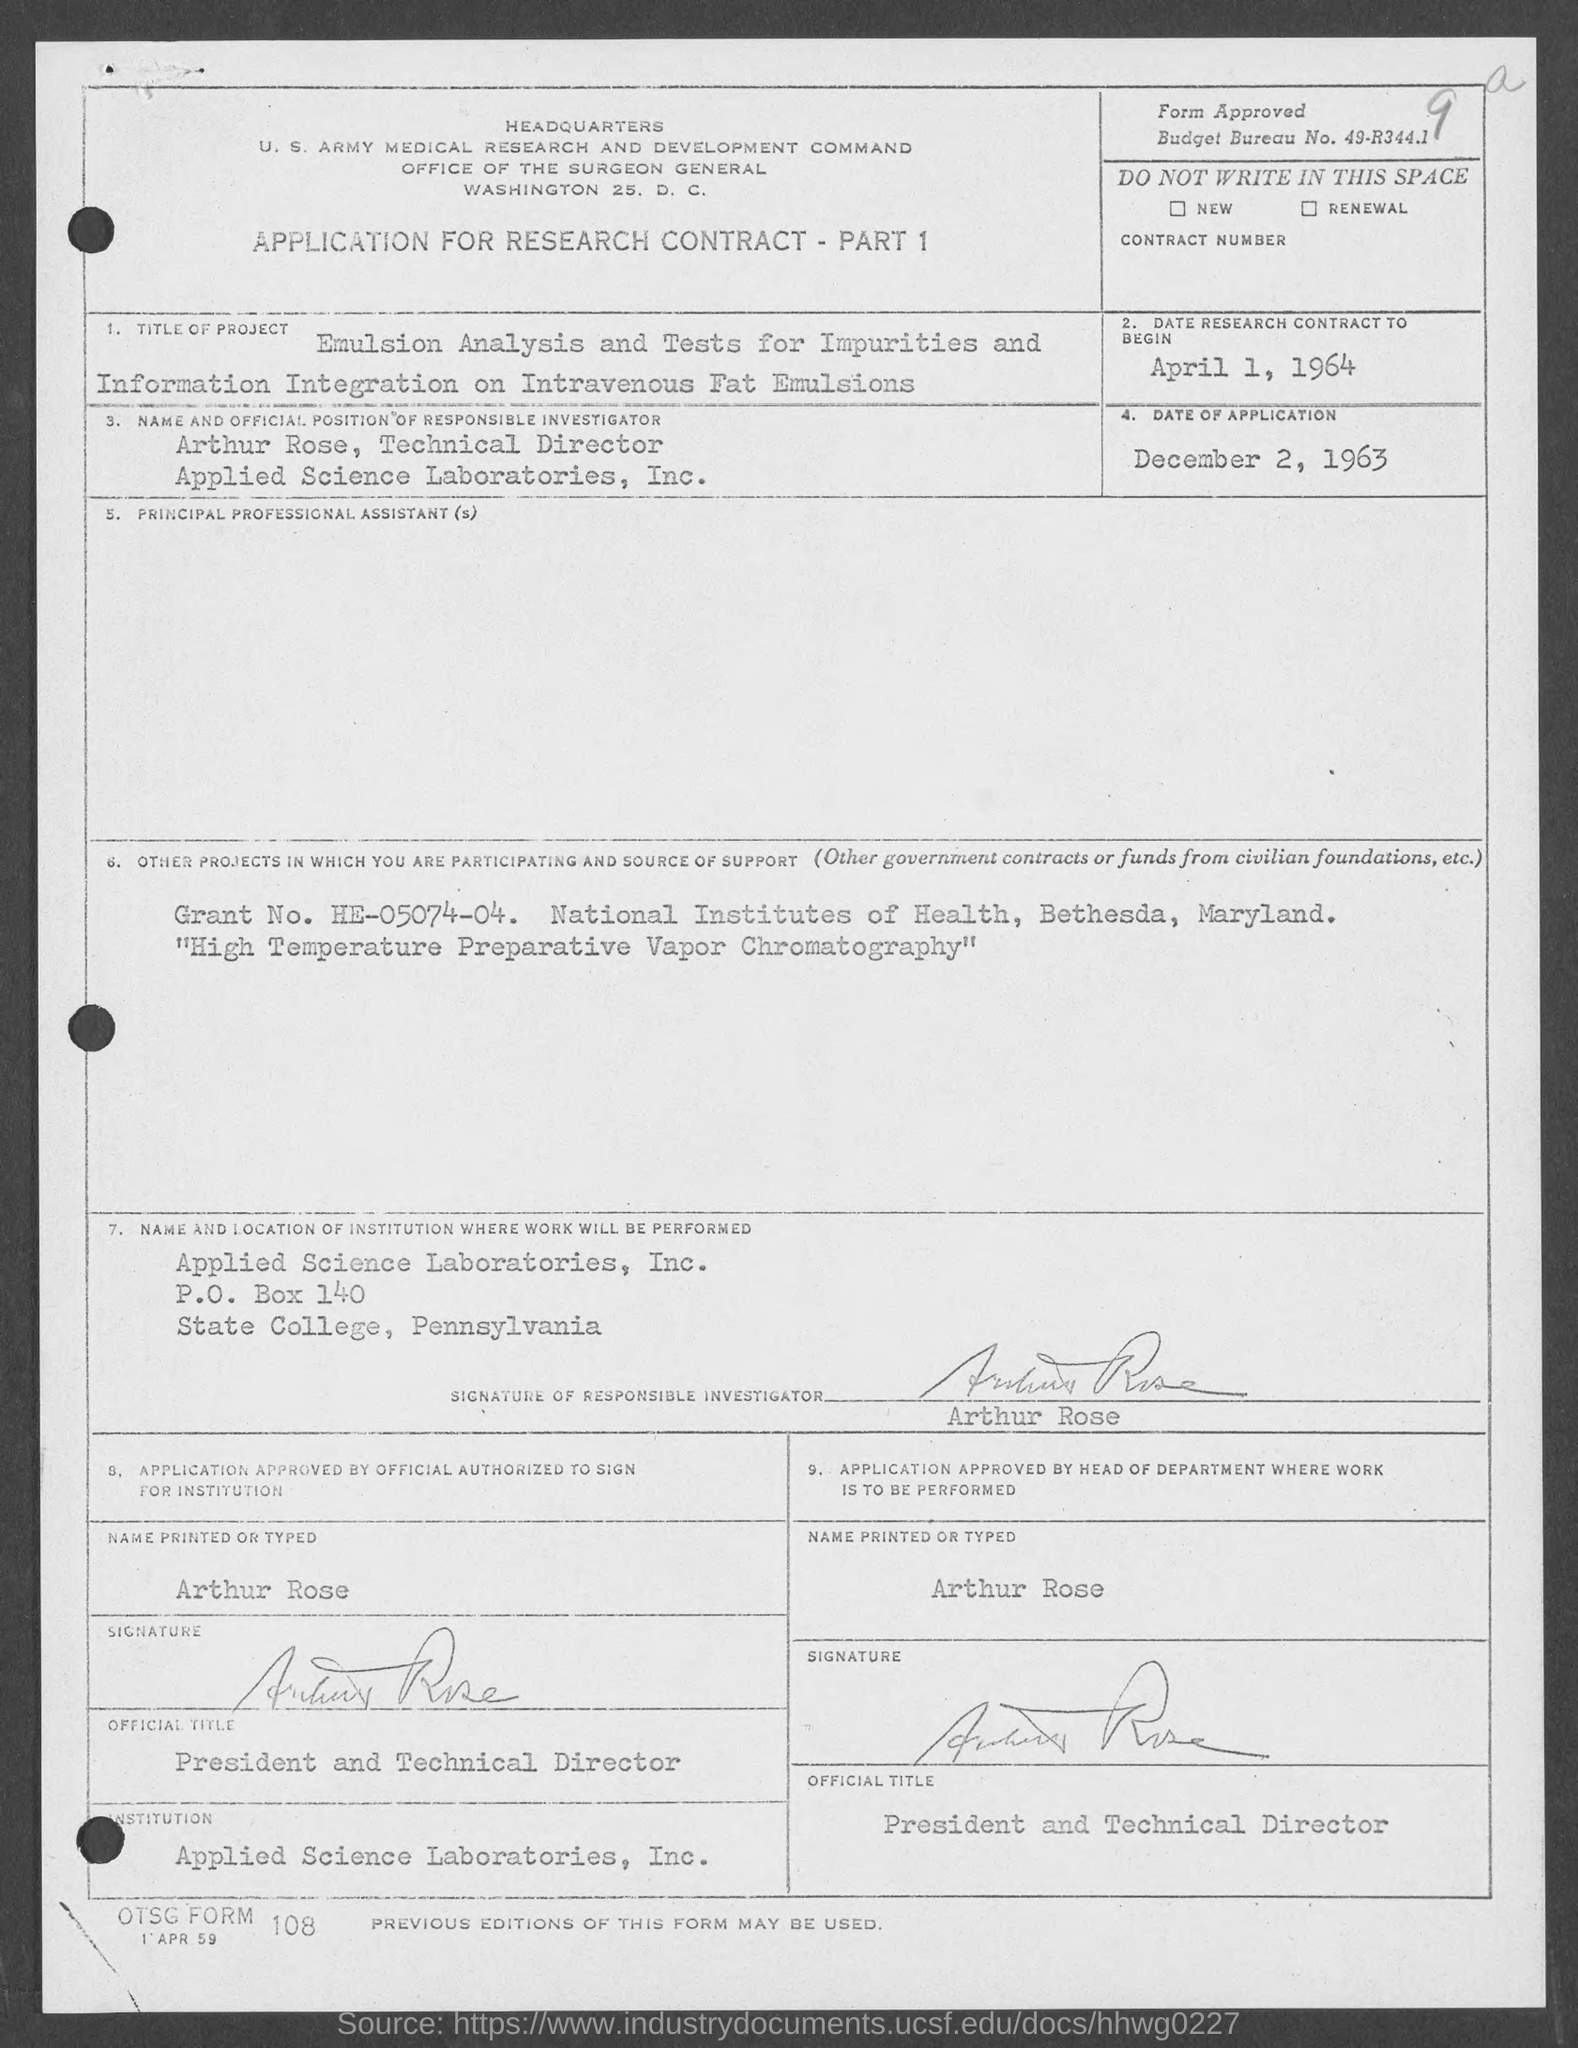What is the budget bureau no. ?
Provide a succinct answer. 49-R344.1. What is the date of research contract to begin ?
Make the answer very short. April 1, 1964. What is the date of application ?
Your response must be concise. December 2, 1963. What is the grant no. ?
Your answer should be very brief. HE-05074-04. In which state is applied science laboratories,inc.at?
Give a very brief answer. Pennsylvania. What is the p.o. box no.?
Give a very brief answer. 140. 